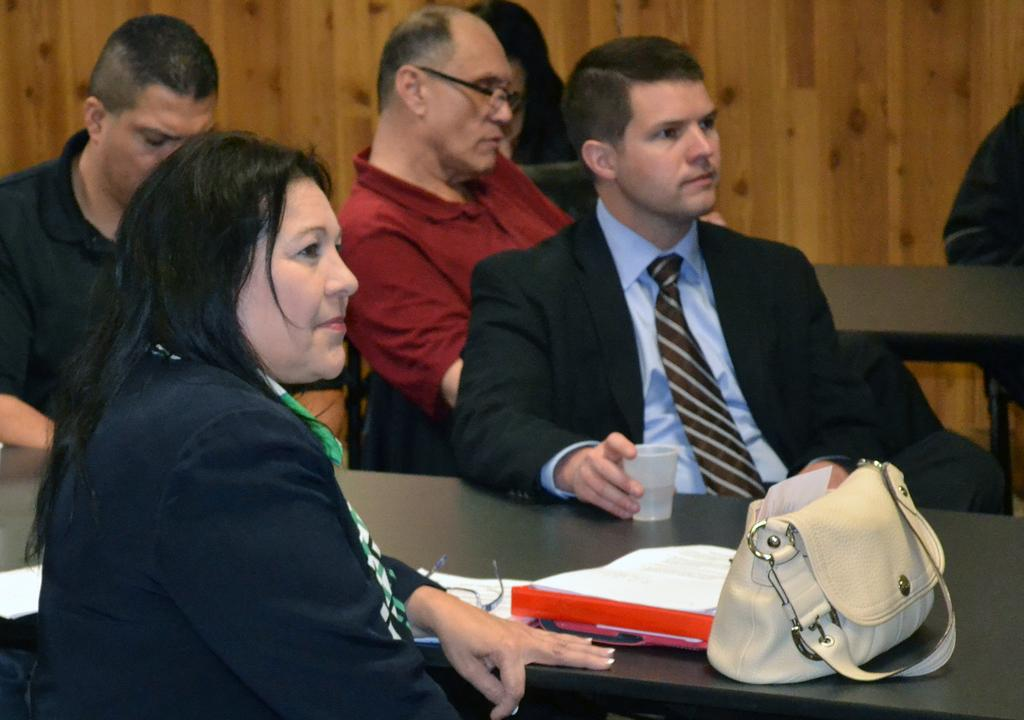What are the people in the image doing? There is a group of people sitting on chairs in the image. What objects can be seen on the table in the image? There is a cup, spectacles, a file, paper, and a handbag on the table in the image. What type of reaction can be seen from the cart in the image? There is no cart present in the image, so it is not possible to observe any reaction from it. 